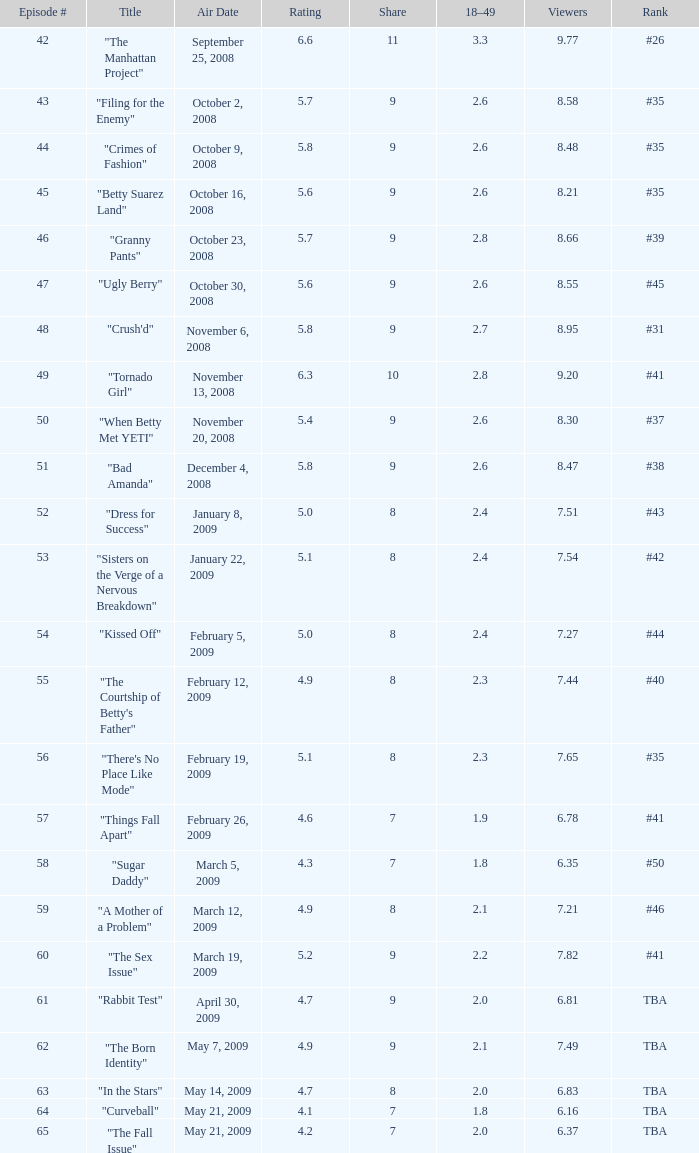What is the lowest Viewers that has an Episode #higher than 58 with a title of "curveball" less than 4.1 rating? None. 